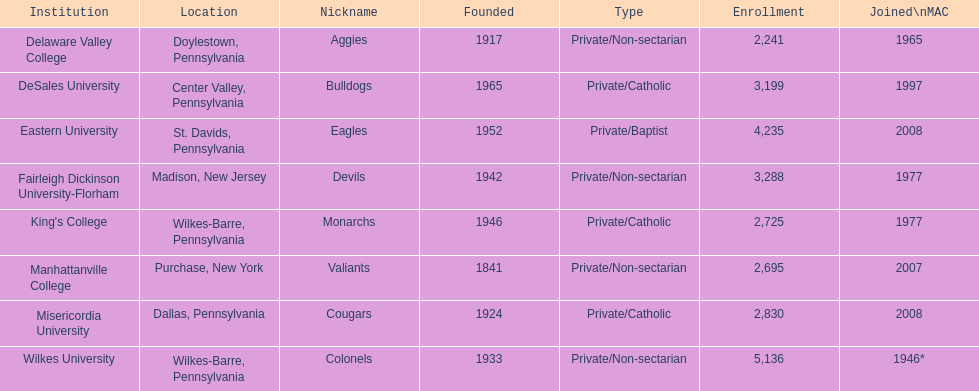How many are enrolled in private/catholic? 8,754. 